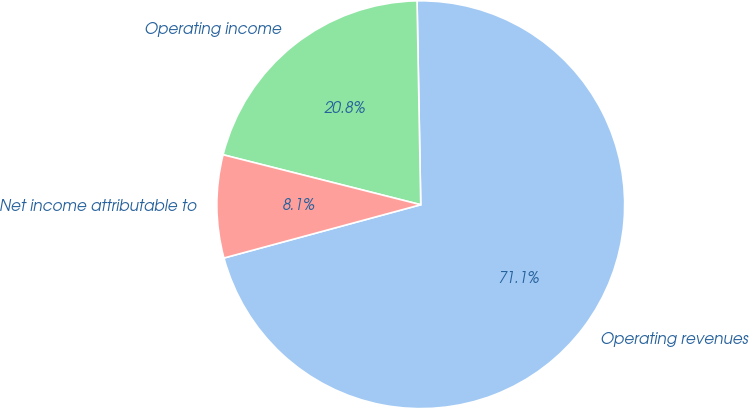<chart> <loc_0><loc_0><loc_500><loc_500><pie_chart><fcel>Operating revenues<fcel>Operating income<fcel>Net income attributable to<nl><fcel>71.08%<fcel>20.77%<fcel>8.15%<nl></chart> 